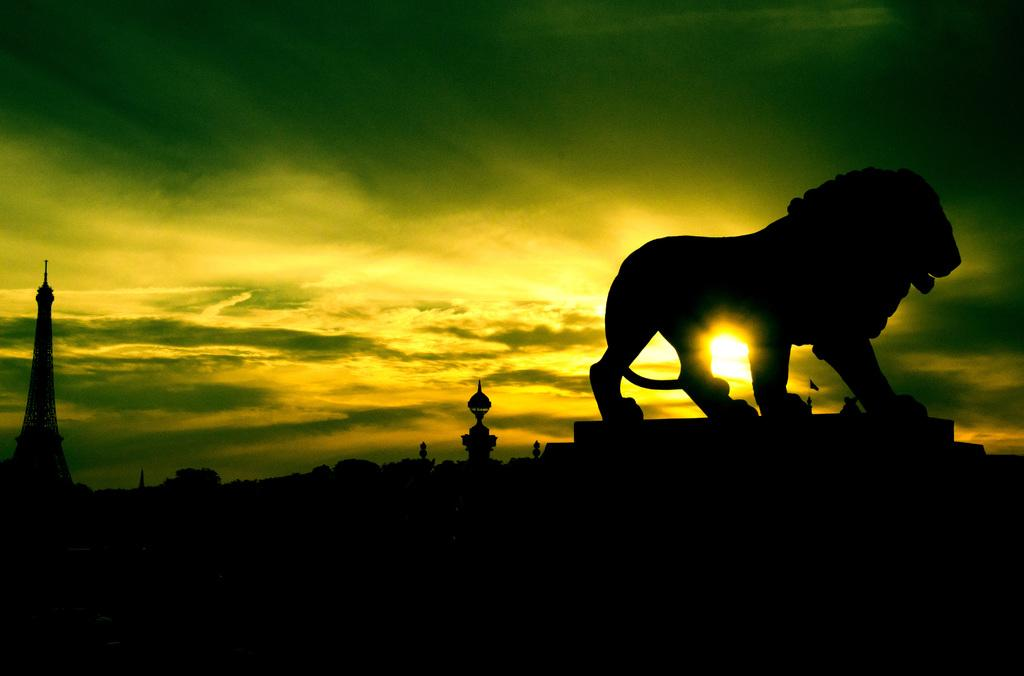What structure is the main subject of the image? There is a tower in the image. What animal can be seen in the image? There is a depiction of a lion in the image. What can be seen in the background of the image? The sky is visible in the background of the image. What celestial body is observable in the sky? The sun is observable in the sky. What language is the lion speaking in the image? Lions do not speak any language, and there is no indication in the image that the lion is speaking. 